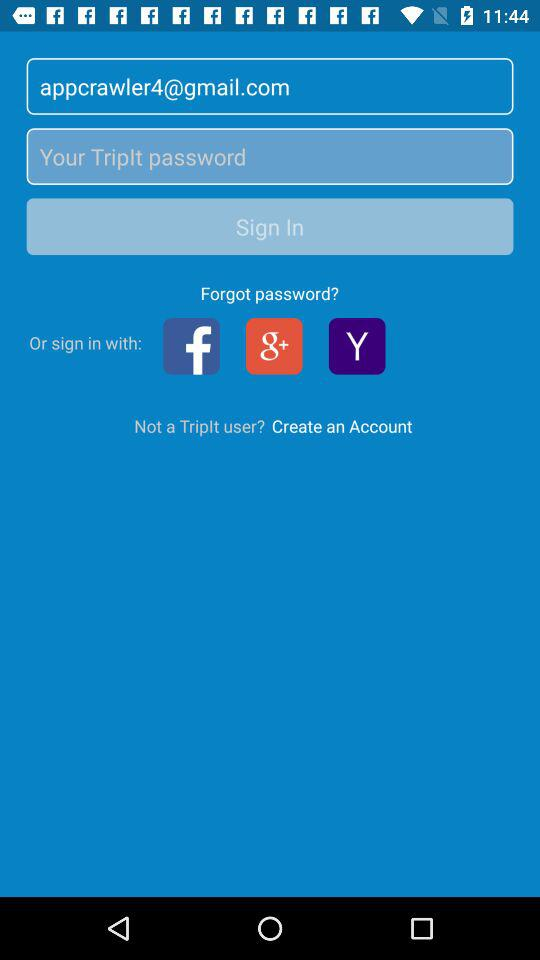What is the email address? The email address is appcrawler4@gmail.com. 